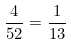Convert formula to latex. <formula><loc_0><loc_0><loc_500><loc_500>\frac { 4 } { 5 2 } = \frac { 1 } { 1 3 }</formula> 